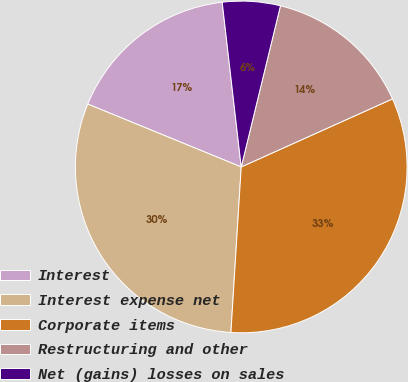Convert chart. <chart><loc_0><loc_0><loc_500><loc_500><pie_chart><fcel>Interest<fcel>Interest expense net<fcel>Corporate items<fcel>Restructuring and other<fcel>Net (gains) losses on sales<nl><fcel>16.98%<fcel>30.2%<fcel>32.72%<fcel>14.47%<fcel>5.63%<nl></chart> 